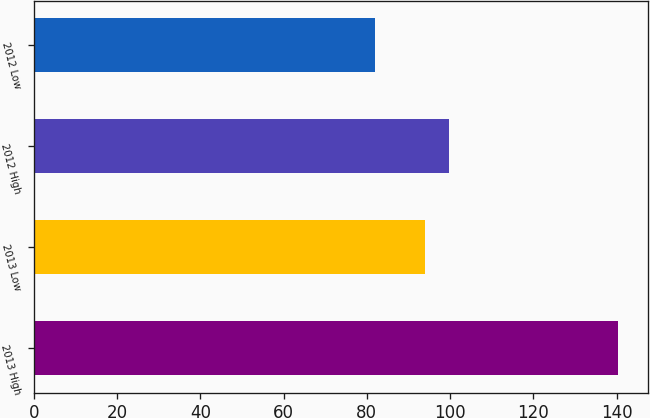<chart> <loc_0><loc_0><loc_500><loc_500><bar_chart><fcel>2013 High<fcel>2013 Low<fcel>2012 High<fcel>2012 Low<nl><fcel>140.43<fcel>93.96<fcel>99.8<fcel>81.99<nl></chart> 